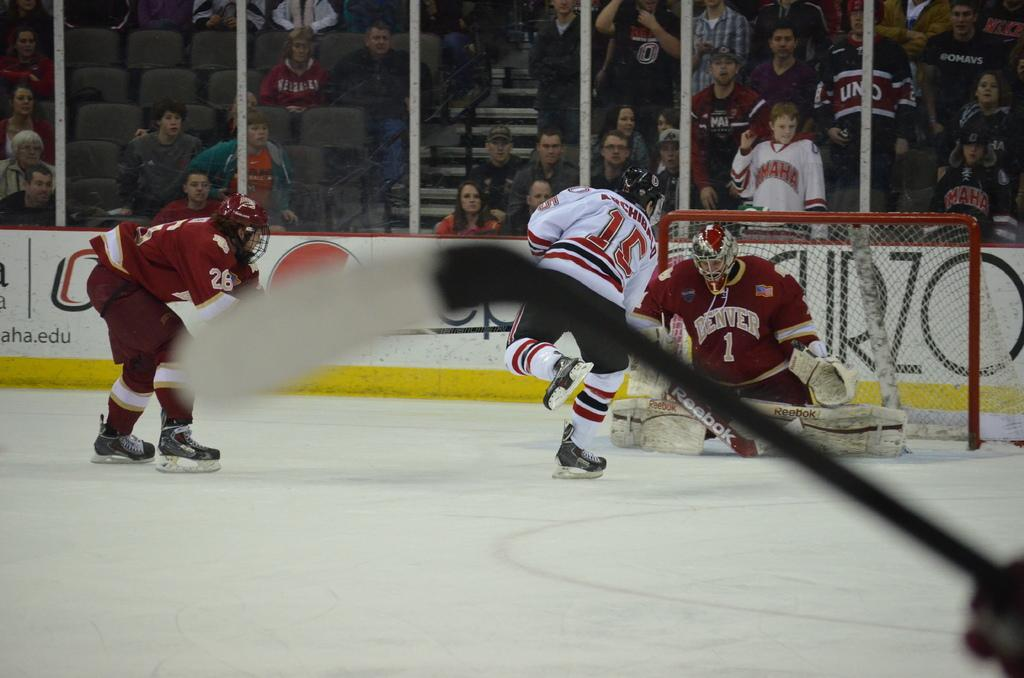<image>
Present a compact description of the photo's key features. The hockey goalie from Denver is trying to block a shot from the player in the 15 jersey. 